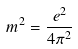Convert formula to latex. <formula><loc_0><loc_0><loc_500><loc_500>m ^ { 2 } = \frac { e ^ { 2 } } { 4 \pi ^ { 2 } }</formula> 